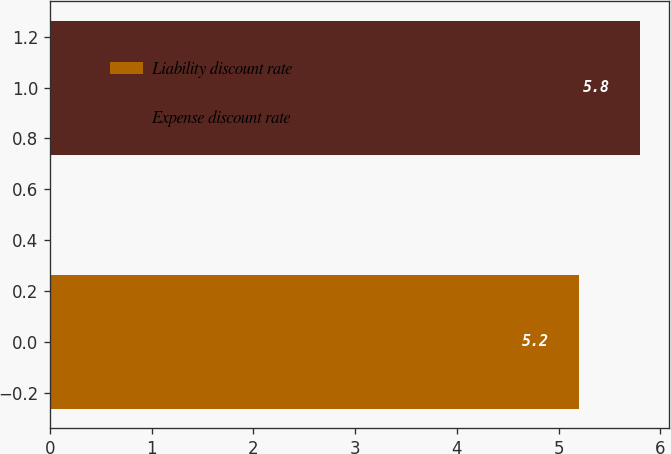Convert chart to OTSL. <chart><loc_0><loc_0><loc_500><loc_500><bar_chart><fcel>Liability discount rate<fcel>Expense discount rate<nl><fcel>5.2<fcel>5.8<nl></chart> 